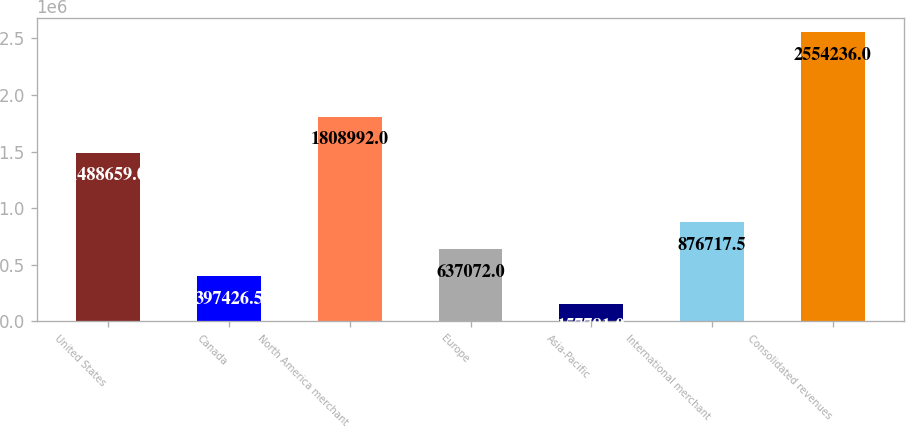Convert chart. <chart><loc_0><loc_0><loc_500><loc_500><bar_chart><fcel>United States<fcel>Canada<fcel>North America merchant<fcel>Europe<fcel>Asia-Pacific<fcel>International merchant<fcel>Consolidated revenues<nl><fcel>1.48866e+06<fcel>397426<fcel>1.80899e+06<fcel>637072<fcel>157781<fcel>876718<fcel>2.55424e+06<nl></chart> 